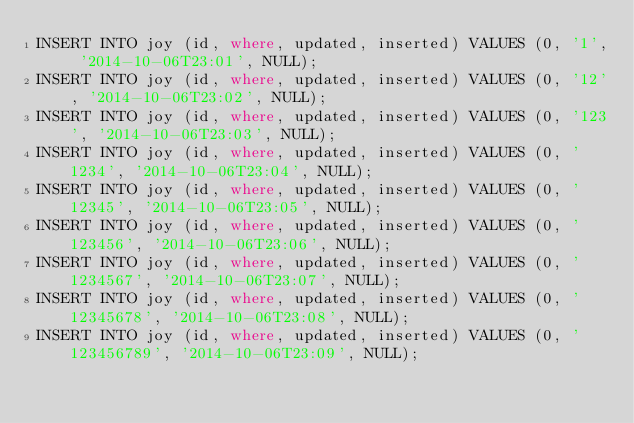Convert code to text. <code><loc_0><loc_0><loc_500><loc_500><_SQL_>INSERT INTO joy (id, where, updated, inserted) VALUES (0, '1', '2014-10-06T23:01', NULL);
INSERT INTO joy (id, where, updated, inserted) VALUES (0, '12', '2014-10-06T23:02', NULL);
INSERT INTO joy (id, where, updated, inserted) VALUES (0, '123', '2014-10-06T23:03', NULL);
INSERT INTO joy (id, where, updated, inserted) VALUES (0, '1234', '2014-10-06T23:04', NULL);
INSERT INTO joy (id, where, updated, inserted) VALUES (0, '12345', '2014-10-06T23:05', NULL);
INSERT INTO joy (id, where, updated, inserted) VALUES (0, '123456', '2014-10-06T23:06', NULL);
INSERT INTO joy (id, where, updated, inserted) VALUES (0, '1234567', '2014-10-06T23:07', NULL);
INSERT INTO joy (id, where, updated, inserted) VALUES (0, '12345678', '2014-10-06T23:08', NULL);
INSERT INTO joy (id, where, updated, inserted) VALUES (0, '123456789', '2014-10-06T23:09', NULL);
</code> 